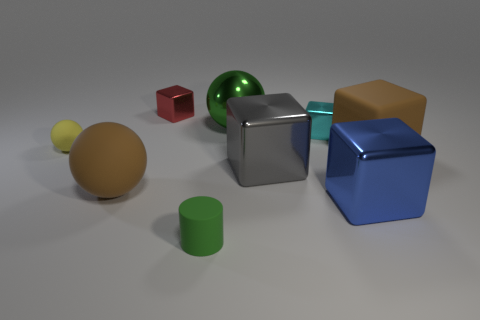How many big balls are the same color as the tiny rubber cylinder?
Make the answer very short. 1. How many other things are the same size as the red thing?
Provide a short and direct response. 3. There is a thing that is behind the yellow thing and in front of the metallic ball; how big is it?
Ensure brevity in your answer.  Small. How many large blue things are the same shape as the red thing?
Your response must be concise. 1. What is the tiny green object made of?
Your response must be concise. Rubber. Is the small red metal thing the same shape as the big gray metallic thing?
Give a very brief answer. Yes. Are there any small cyan things that have the same material as the small sphere?
Your answer should be compact. No. There is a cube that is both behind the small yellow rubber ball and on the right side of the large green shiny thing; what color is it?
Ensure brevity in your answer.  Cyan. What is the brown thing to the left of the tiny cyan block made of?
Make the answer very short. Rubber. Is there a small yellow rubber thing of the same shape as the big blue object?
Keep it short and to the point. No. 